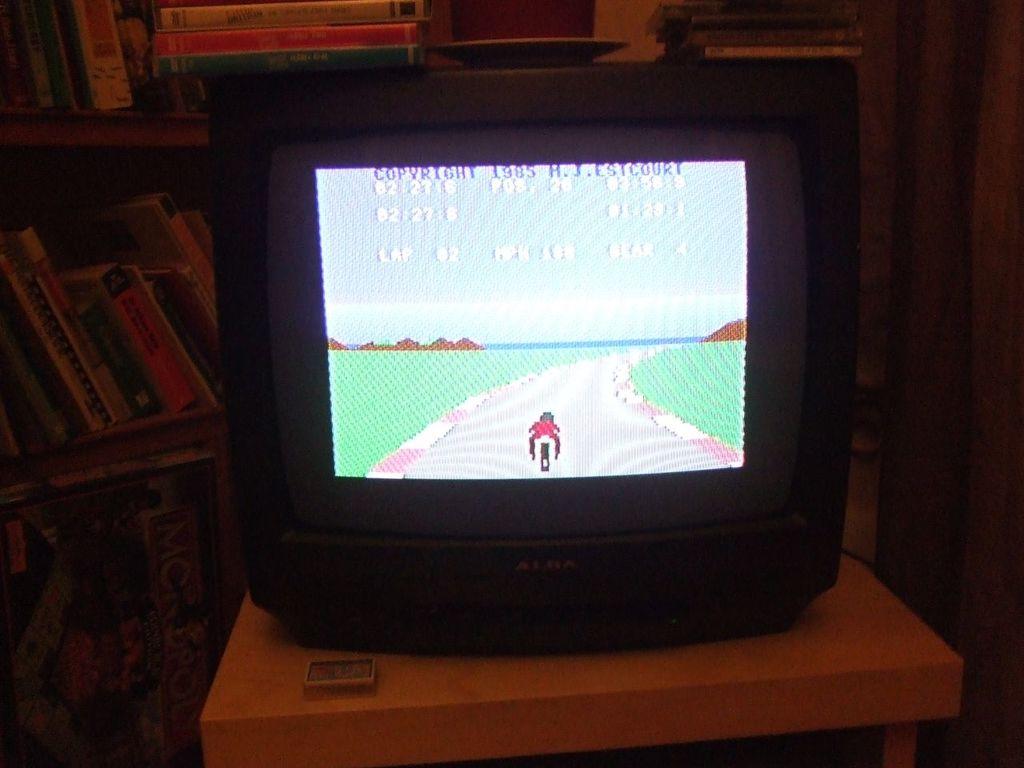What is the copywrite of this ?
Your answer should be compact. 1985. Who's the tv manufacturer?
Provide a short and direct response. Unanswerable. 